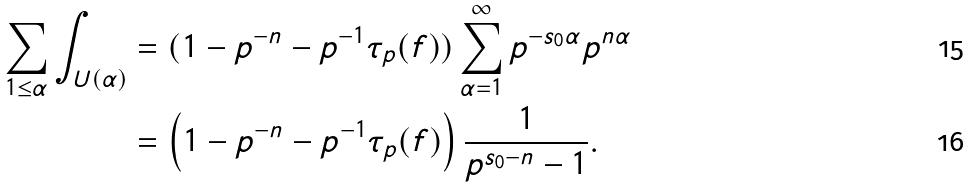<formula> <loc_0><loc_0><loc_500><loc_500>\sum _ { 1 \leq \alpha } \int _ { U ( \alpha ) } & = ( 1 - p ^ { - n } - p ^ { - 1 } \tau _ { p } ( f ) ) \sum _ { \alpha = 1 } ^ { \infty } p ^ { - s _ { 0 } \alpha } p ^ { n \alpha } \\ & = \left ( 1 - p ^ { - n } - p ^ { - 1 } \tau _ { p } ( f ) \right ) \frac { 1 } { p ^ { s _ { 0 } - n } - 1 } .</formula> 